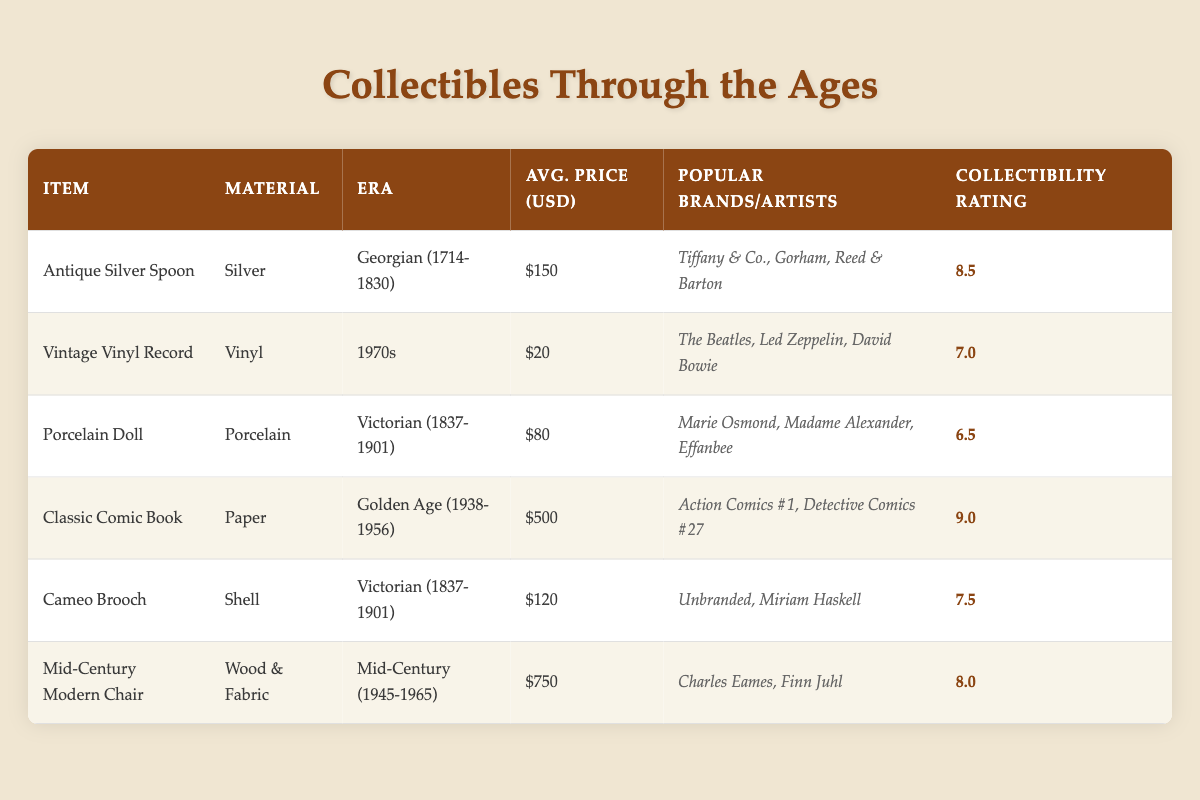What is the average price of the collectibles listed? To find the average price, add the prices: 150 + 20 + 80 + 500 + 120 + 750 = 1620. Then divide by the number of items, which is 6. So, 1620 / 6 = 270.
Answer: 270 Is the collectibility rating of the Porcelain Doll greater than 7? The collectibility rating of the Porcelain Doll is 6.5, which is less than 7.
Answer: No Which item has the highest collectibility rating, and what is it? The table shows the collectibility ratings: Antique Silver Spoon (8.5), Vintage Vinyl Record (7.0), Porcelain Doll (6.5), Classic Comic Book (9.0), Cameo Brooch (7.5), Mid-Century Modern Chair (8.0). The highest is 9.0 for the Classic Comic Book.
Answer: Classic Comic Book, 9.0 How many collectible items are from the Victorian era? There are two items from the Victorian era: the Porcelain Doll and the Cameo Brooch.
Answer: 2 What is the price difference between the Mid-Century Modern Chair and the Classic Comic Book? The price of the Mid-Century Modern Chair is 750 and the Classic Comic Book is 500. The difference is 750 - 500 = 250.
Answer: 250 Is there a collectible item from the 1970s that has a collectibility rating above 6? The Vintage Vinyl Record is from the 1970s with a collectibility rating of 7.0, which is above 6.
Answer: Yes Which material corresponds to the collectible item with the lowest average price? The lowest average price is for the Vintage Vinyl Record at 20 USD, which is made of Vinyl.
Answer: Vinyl How many collectibles from the Victorian era have a collectibility rating over 7? The Porcelain Doll has a collectibility rating of 6.5 and the Cameo Brooch has a rating of 7.5. Only the Cameo Brooch, with a rating of 7.5, is over 7, thus there is 1 collectible.
Answer: 1 What is the total average price of collectibles made of Porcelain? Only the Porcelain Doll is made of Porcelain, with an average price of 80. Therefore, the average price for collectibles made of Porcelain is simply 80.
Answer: 80 